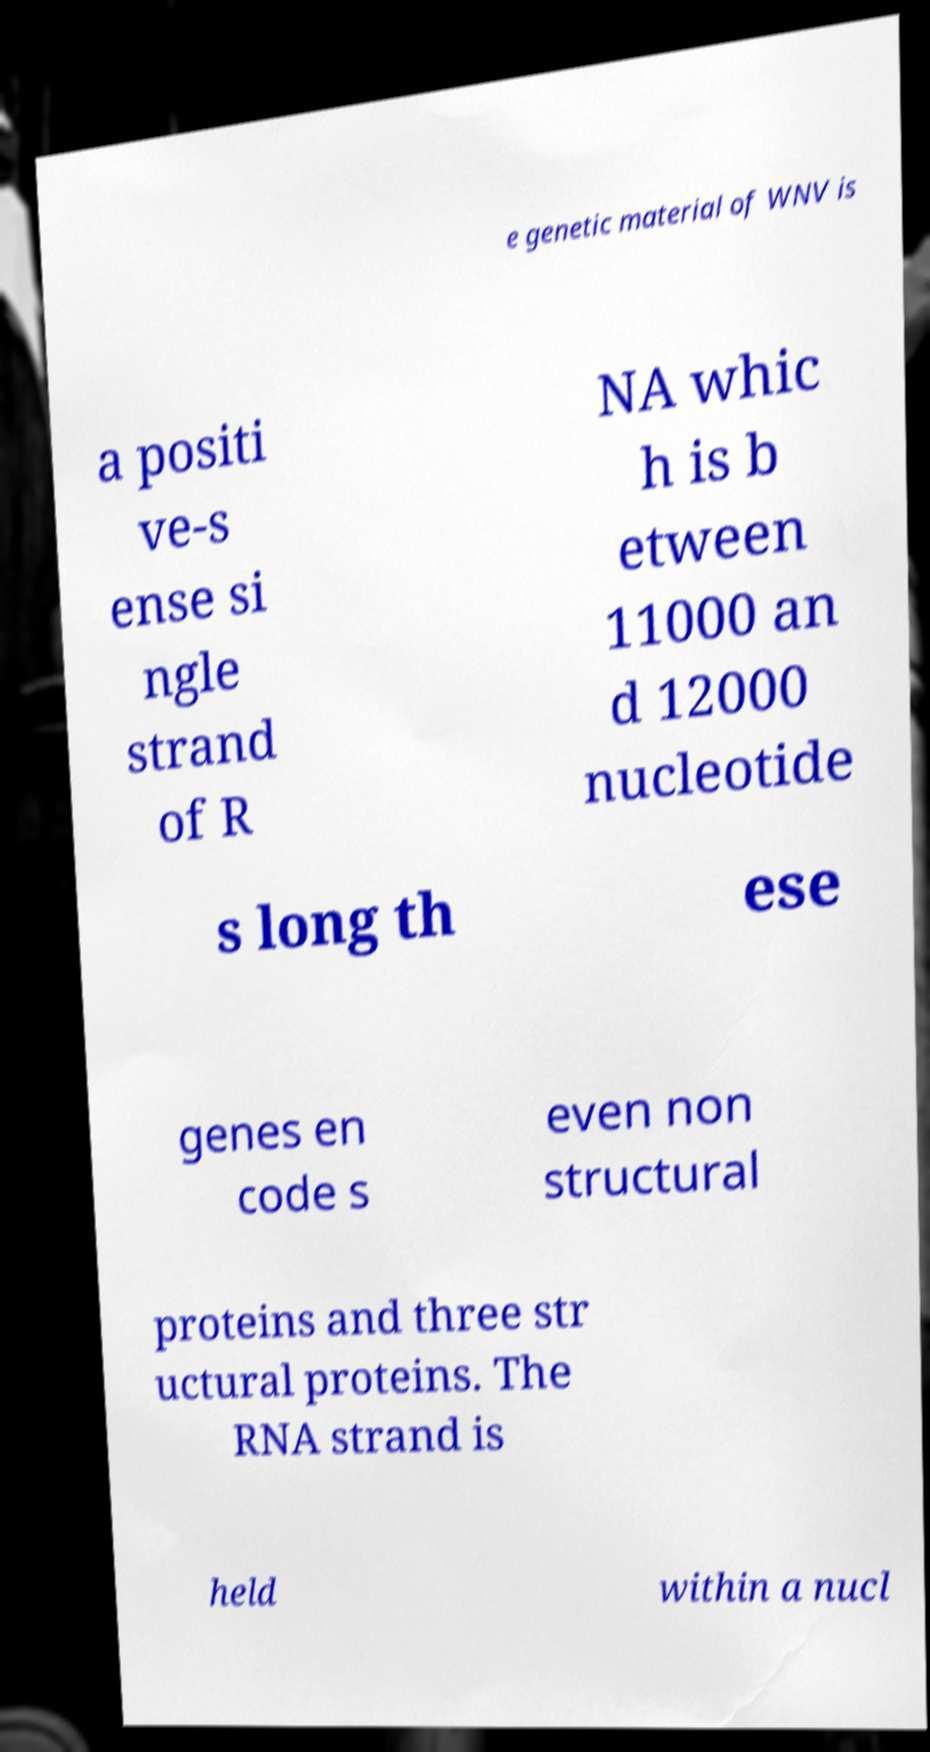Could you extract and type out the text from this image? e genetic material of WNV is a positi ve-s ense si ngle strand of R NA whic h is b etween 11000 an d 12000 nucleotide s long th ese genes en code s even non structural proteins and three str uctural proteins. The RNA strand is held within a nucl 